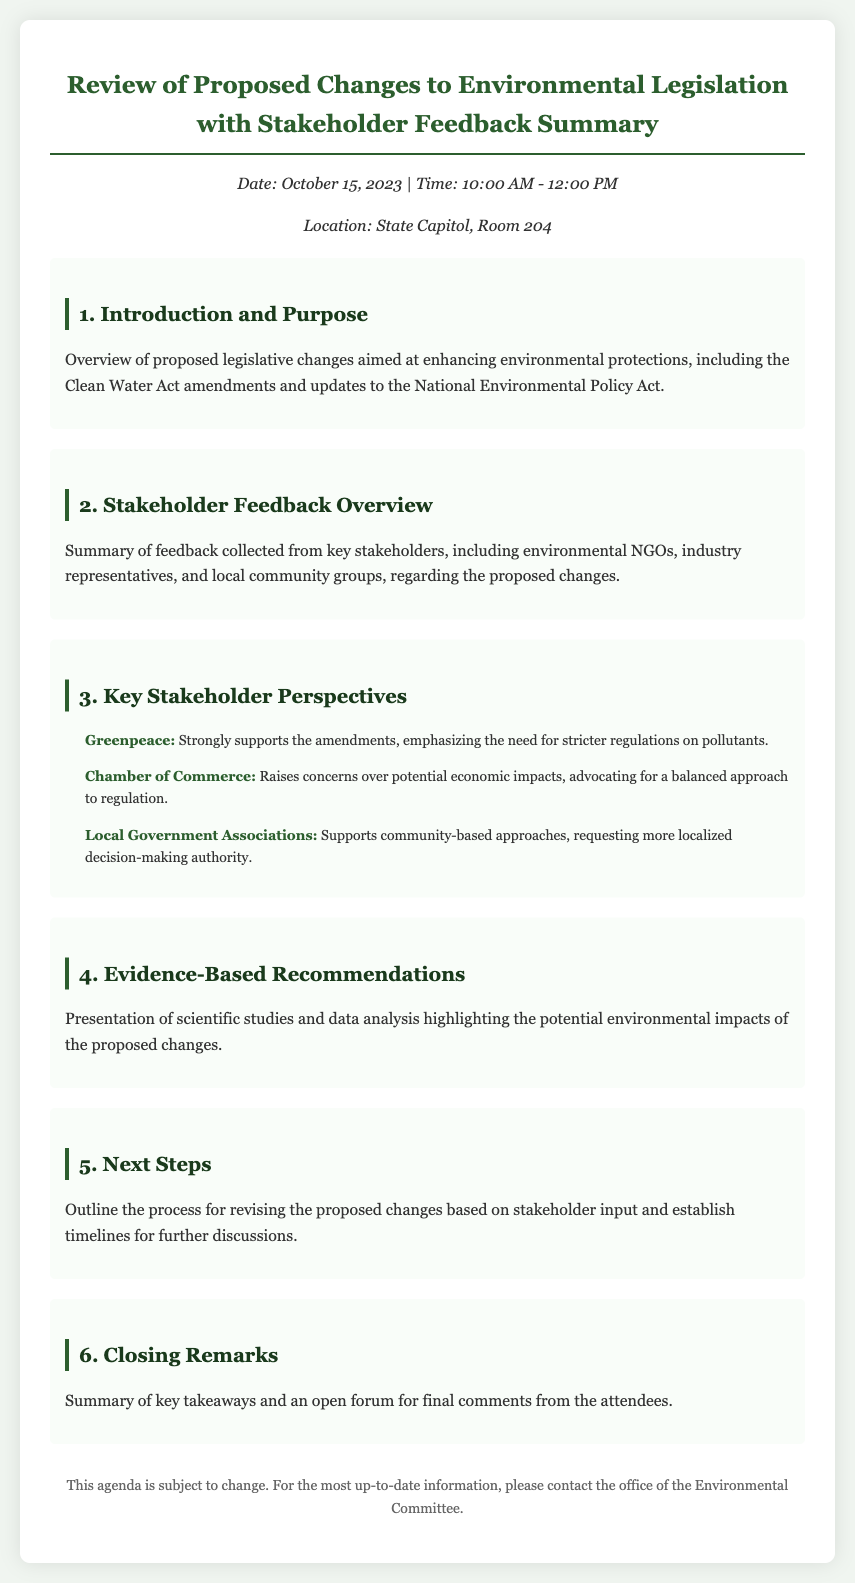What is the date of the meeting? The meeting date is mentioned at the beginning of the document.
Answer: October 15, 2023 What is the location of the meeting? The location is provided in the header information section.
Answer: State Capitol, Room 204 What are the proposed changes aimed at? The introduction section describes the purpose of the proposed changes.
Answer: Enhancing environmental protections Which organization strongly supports the amendments? The key stakeholder perspectives section lists the organization that supports the amendments.
Answer: Greenpeace What does the Chamber of Commerce advocate for? The stakeholder feedback overview mentions the stance of the Chamber of Commerce.
Answer: A balanced approach to regulation How long is the meeting scheduled for? The duration of the meeting is provided in the header information.
Answer: 2 hours Which act is mentioned in the introduction? The introduction section references the legislative acts included in the proposed changes.
Answer: Clean Water Act What is presented in the fourth agenda item? The fourth item outlines what will be shown during that part of the meeting.
Answer: Evidence-based recommendations What does the final agenda item include? The last agenda item specifies what will happen at the conclusion of the meeting.
Answer: An open forum for final comments 